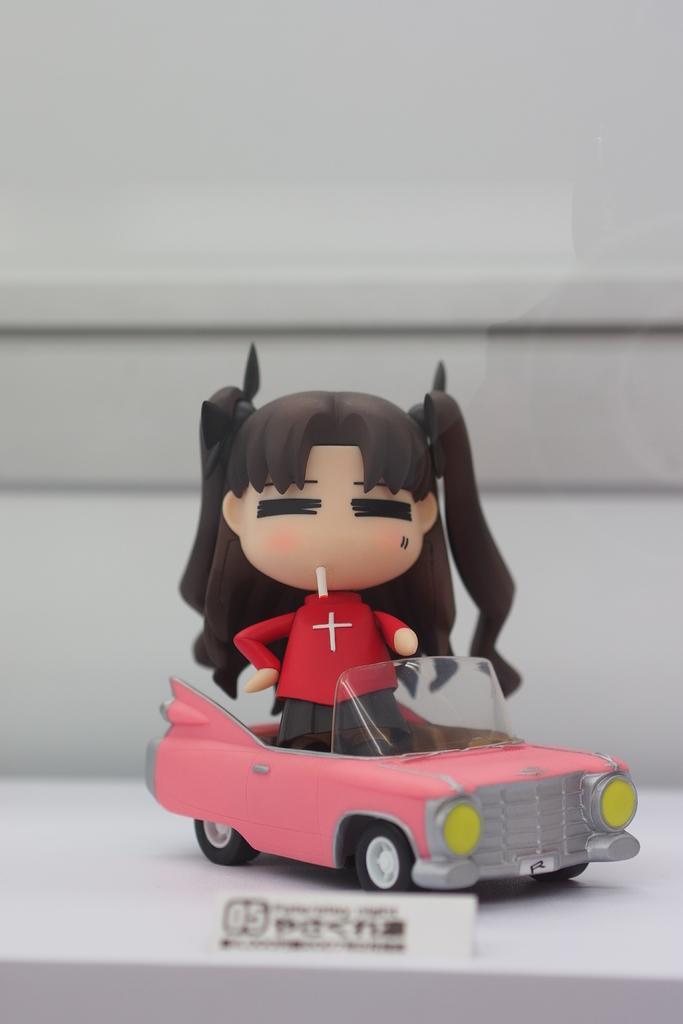How would you summarize this image in a sentence or two? This image is taken indoors. In the background there is a wall. At the bottom of the image there is a table and there is a name board with a text on it. In the middle of the image there is a toy car on the table and there is a toy girl in the car. 